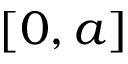Convert formula to latex. <formula><loc_0><loc_0><loc_500><loc_500>[ 0 , a ]</formula> 